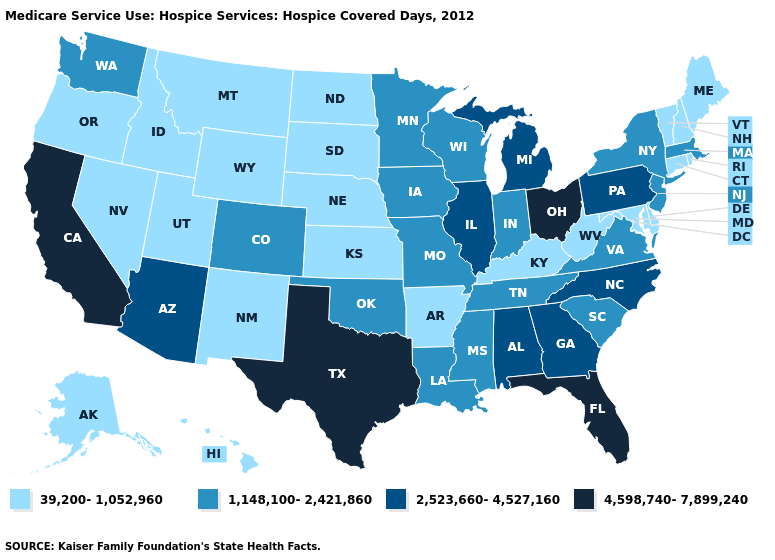Does Ohio have a higher value than Texas?
Short answer required. No. Does the map have missing data?
Short answer required. No. Name the states that have a value in the range 39,200-1,052,960?
Concise answer only. Alaska, Arkansas, Connecticut, Delaware, Hawaii, Idaho, Kansas, Kentucky, Maine, Maryland, Montana, Nebraska, Nevada, New Hampshire, New Mexico, North Dakota, Oregon, Rhode Island, South Dakota, Utah, Vermont, West Virginia, Wyoming. How many symbols are there in the legend?
Quick response, please. 4. Name the states that have a value in the range 4,598,740-7,899,240?
Give a very brief answer. California, Florida, Ohio, Texas. Among the states that border Delaware , which have the highest value?
Concise answer only. Pennsylvania. Which states have the lowest value in the USA?
Answer briefly. Alaska, Arkansas, Connecticut, Delaware, Hawaii, Idaho, Kansas, Kentucky, Maine, Maryland, Montana, Nebraska, Nevada, New Hampshire, New Mexico, North Dakota, Oregon, Rhode Island, South Dakota, Utah, Vermont, West Virginia, Wyoming. Does Massachusetts have the highest value in the Northeast?
Keep it brief. No. What is the value of Iowa?
Short answer required. 1,148,100-2,421,860. What is the value of Georgia?
Short answer required. 2,523,660-4,527,160. What is the highest value in states that border New York?
Keep it brief. 2,523,660-4,527,160. Among the states that border North Carolina , does Georgia have the lowest value?
Be succinct. No. Does Mississippi have the highest value in the USA?
Keep it brief. No. Is the legend a continuous bar?
Give a very brief answer. No. Does Ohio have the highest value in the MidWest?
Quick response, please. Yes. 